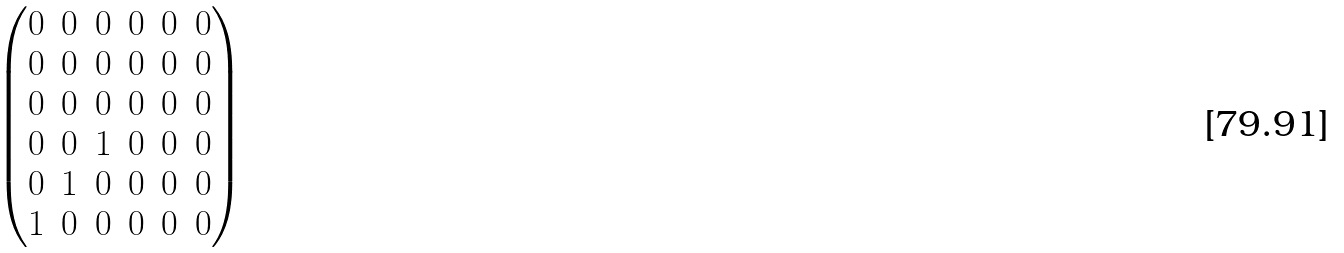Convert formula to latex. <formula><loc_0><loc_0><loc_500><loc_500>\begin{pmatrix} 0 & 0 & 0 & 0 & 0 & 0 \\ 0 & 0 & 0 & 0 & 0 & 0 \\ 0 & 0 & 0 & 0 & 0 & 0 \\ 0 & 0 & 1 & 0 & 0 & 0 \\ 0 & 1 & 0 & 0 & 0 & 0 \\ 1 & 0 & 0 & 0 & 0 & 0 \end{pmatrix}</formula> 